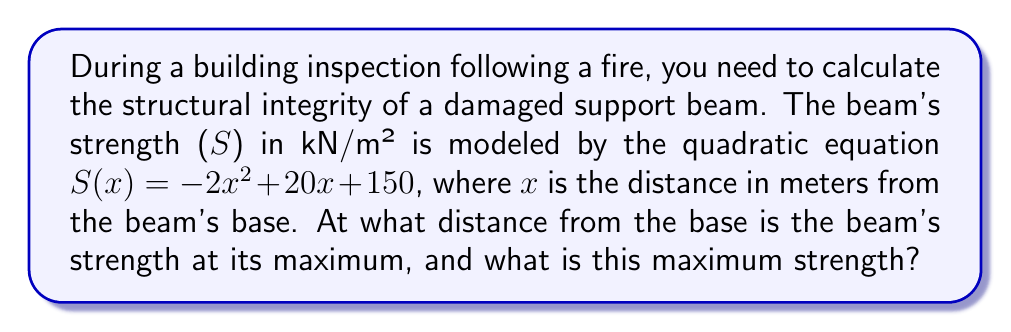Give your solution to this math problem. To solve this problem, we'll follow these steps:

1) The quadratic equation for the beam's strength is given by:
   $$S(x) = -2x^2 + 20x + 150$$

2) To find the maximum value of a quadratic function, we need to find the vertex of the parabola. For a quadratic function in the form $f(x) = ax^2 + bx + c$, the x-coordinate of the vertex is given by $x = -\frac{b}{2a}$.

3) In our equation, $a = -2$ and $b = 20$. Let's substitute these values:
   $$x = -\frac{20}{2(-2)} = -\frac{20}{-4} = 5$$

4) This means the beam's strength is at its maximum 5 meters from the base.

5) To find the maximum strength, we substitute x = 5 into our original equation:
   $$S(5) = -2(5)^2 + 20(5) + 150$$
   $$= -2(25) + 100 + 150$$
   $$= -50 + 100 + 150$$
   $$= 200$$

Therefore, the maximum strength is 200 kN/m² and occurs 5 meters from the base of the beam.
Answer: 5 meters from base; 200 kN/m² 